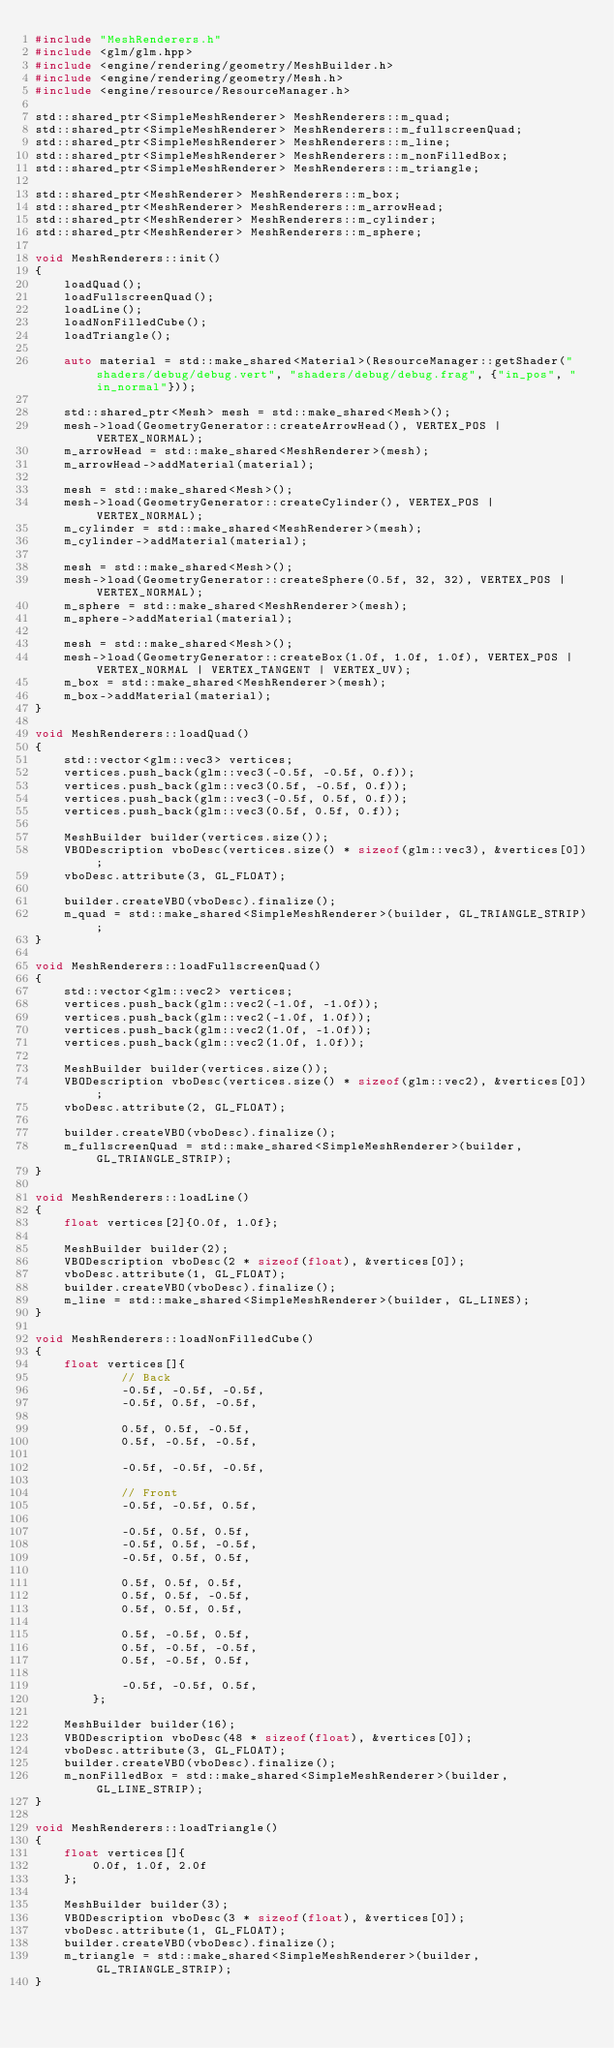Convert code to text. <code><loc_0><loc_0><loc_500><loc_500><_C++_>#include "MeshRenderers.h"
#include <glm/glm.hpp>
#include <engine/rendering/geometry/MeshBuilder.h>
#include <engine/rendering/geometry/Mesh.h>
#include <engine/resource/ResourceManager.h>

std::shared_ptr<SimpleMeshRenderer> MeshRenderers::m_quad;
std::shared_ptr<SimpleMeshRenderer> MeshRenderers::m_fullscreenQuad;
std::shared_ptr<SimpleMeshRenderer> MeshRenderers::m_line;
std::shared_ptr<SimpleMeshRenderer> MeshRenderers::m_nonFilledBox;
std::shared_ptr<SimpleMeshRenderer> MeshRenderers::m_triangle;

std::shared_ptr<MeshRenderer> MeshRenderers::m_box;
std::shared_ptr<MeshRenderer> MeshRenderers::m_arrowHead;
std::shared_ptr<MeshRenderer> MeshRenderers::m_cylinder;
std::shared_ptr<MeshRenderer> MeshRenderers::m_sphere;

void MeshRenderers::init()
{
    loadQuad();
    loadFullscreenQuad();
    loadLine();
    loadNonFilledCube();
    loadTriangle();

    auto material = std::make_shared<Material>(ResourceManager::getShader("shaders/debug/debug.vert", "shaders/debug/debug.frag", {"in_pos", "in_normal"}));

    std::shared_ptr<Mesh> mesh = std::make_shared<Mesh>();
    mesh->load(GeometryGenerator::createArrowHead(), VERTEX_POS | VERTEX_NORMAL);
    m_arrowHead = std::make_shared<MeshRenderer>(mesh);
    m_arrowHead->addMaterial(material);

    mesh = std::make_shared<Mesh>();
    mesh->load(GeometryGenerator::createCylinder(), VERTEX_POS | VERTEX_NORMAL);
    m_cylinder = std::make_shared<MeshRenderer>(mesh);
    m_cylinder->addMaterial(material);

    mesh = std::make_shared<Mesh>();
    mesh->load(GeometryGenerator::createSphere(0.5f, 32, 32), VERTEX_POS | VERTEX_NORMAL);
    m_sphere = std::make_shared<MeshRenderer>(mesh);
    m_sphere->addMaterial(material);

    mesh = std::make_shared<Mesh>();
    mesh->load(GeometryGenerator::createBox(1.0f, 1.0f, 1.0f), VERTEX_POS | VERTEX_NORMAL | VERTEX_TANGENT | VERTEX_UV);
    m_box = std::make_shared<MeshRenderer>(mesh);
    m_box->addMaterial(material);
}

void MeshRenderers::loadQuad()
{
    std::vector<glm::vec3> vertices;
    vertices.push_back(glm::vec3(-0.5f, -0.5f, 0.f));
    vertices.push_back(glm::vec3(0.5f, -0.5f, 0.f));
    vertices.push_back(glm::vec3(-0.5f, 0.5f, 0.f));
    vertices.push_back(glm::vec3(0.5f, 0.5f, 0.f));

    MeshBuilder builder(vertices.size());
    VBODescription vboDesc(vertices.size() * sizeof(glm::vec3), &vertices[0]);
    vboDesc.attribute(3, GL_FLOAT);

    builder.createVBO(vboDesc).finalize();
    m_quad = std::make_shared<SimpleMeshRenderer>(builder, GL_TRIANGLE_STRIP);
}

void MeshRenderers::loadFullscreenQuad()
{
    std::vector<glm::vec2> vertices;
    vertices.push_back(glm::vec2(-1.0f, -1.0f));
    vertices.push_back(glm::vec2(-1.0f, 1.0f));
    vertices.push_back(glm::vec2(1.0f, -1.0f));
    vertices.push_back(glm::vec2(1.0f, 1.0f));

    MeshBuilder builder(vertices.size());
    VBODescription vboDesc(vertices.size() * sizeof(glm::vec2), &vertices[0]);
    vboDesc.attribute(2, GL_FLOAT);

    builder.createVBO(vboDesc).finalize();
    m_fullscreenQuad = std::make_shared<SimpleMeshRenderer>(builder, GL_TRIANGLE_STRIP);
}

void MeshRenderers::loadLine()
{
    float vertices[2]{0.0f, 1.0f};

    MeshBuilder builder(2);
    VBODescription vboDesc(2 * sizeof(float), &vertices[0]);
    vboDesc.attribute(1, GL_FLOAT);
    builder.createVBO(vboDesc).finalize();
    m_line = std::make_shared<SimpleMeshRenderer>(builder, GL_LINES);
}

void MeshRenderers::loadNonFilledCube()
{
    float vertices[]{
            // Back
            -0.5f, -0.5f, -0.5f,
            -0.5f, 0.5f, -0.5f,

            0.5f, 0.5f, -0.5f,
            0.5f, -0.5f, -0.5f,

            -0.5f, -0.5f, -0.5f,

            // Front
            -0.5f, -0.5f, 0.5f,

            -0.5f, 0.5f, 0.5f,
            -0.5f, 0.5f, -0.5f,
            -0.5f, 0.5f, 0.5f,

            0.5f, 0.5f, 0.5f,
            0.5f, 0.5f, -0.5f,
            0.5f, 0.5f, 0.5f,

            0.5f, -0.5f, 0.5f,
            0.5f, -0.5f, -0.5f,
            0.5f, -0.5f, 0.5f,

            -0.5f, -0.5f, 0.5f,
        };

    MeshBuilder builder(16);
    VBODescription vboDesc(48 * sizeof(float), &vertices[0]);
    vboDesc.attribute(3, GL_FLOAT);
    builder.createVBO(vboDesc).finalize();
    m_nonFilledBox = std::make_shared<SimpleMeshRenderer>(builder, GL_LINE_STRIP);
}

void MeshRenderers::loadTriangle()
{
    float vertices[]{
        0.0f, 1.0f, 2.0f
    };

    MeshBuilder builder(3);
    VBODescription vboDesc(3 * sizeof(float), &vertices[0]);
    vboDesc.attribute(1, GL_FLOAT);
    builder.createVBO(vboDesc).finalize();
    m_triangle = std::make_shared<SimpleMeshRenderer>(builder, GL_TRIANGLE_STRIP);
}
</code> 